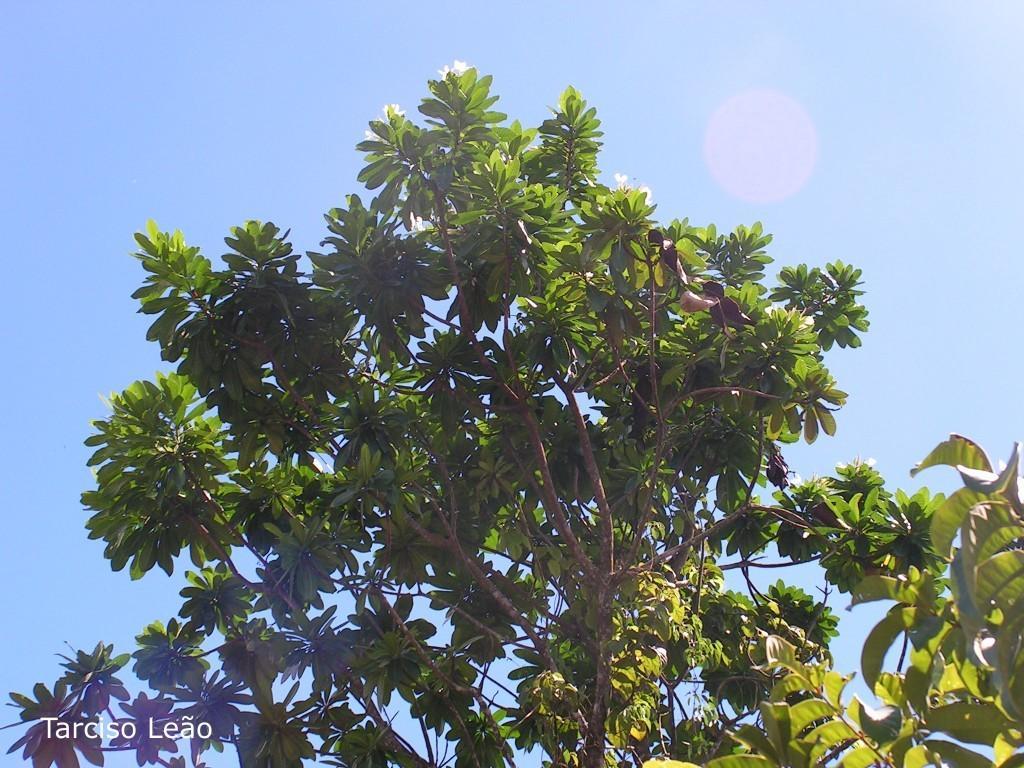Could you give a brief overview of what you see in this image? In this picture I can see some flowers to the trees. 